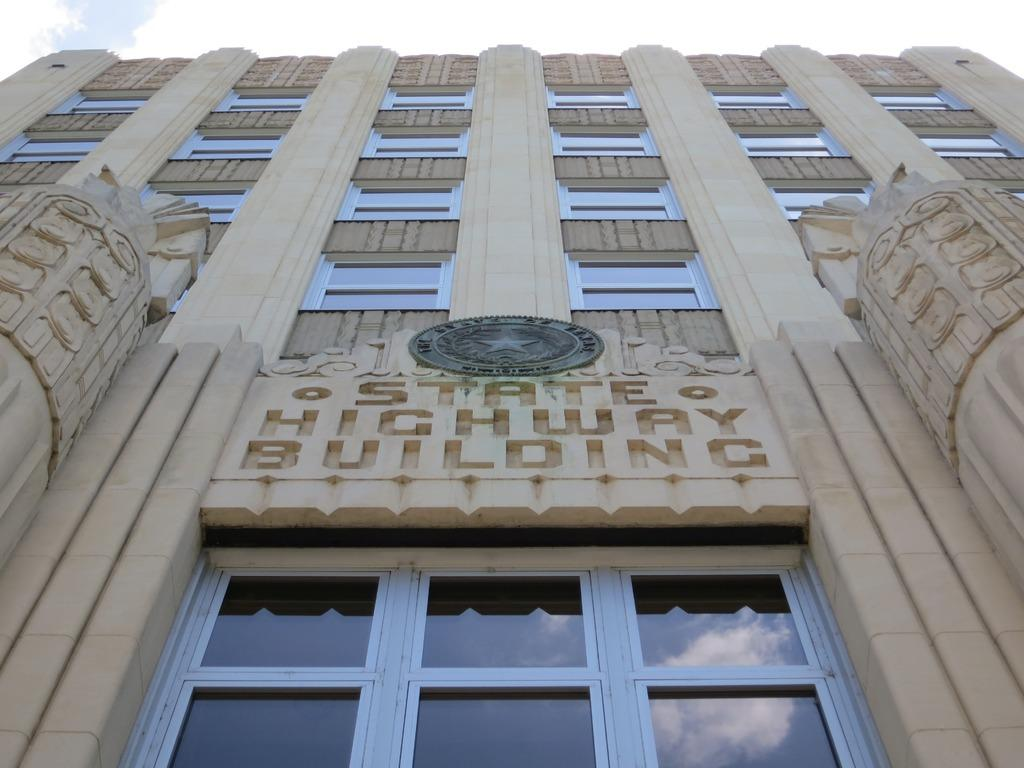What type of structure is present in the image? There is a building in the image. What are some features of the building? The building has windows, pillars, and doors. Is there any text or symbol on the building? Yes, there is text written on the building and a logo on the building. What can be seen in the background of the image? The sky is visible in the background of the image. What territory does the van in the image belong to? There is no van present in the image, so it is not possible to determine which territory it might belong to. 